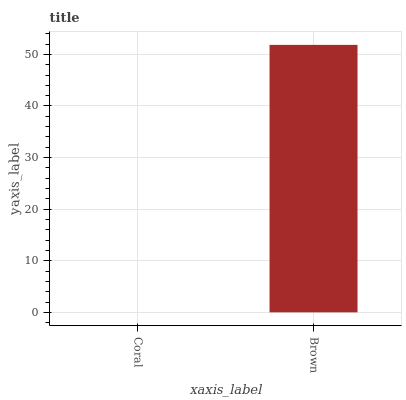Is Brown the minimum?
Answer yes or no. No. Is Brown greater than Coral?
Answer yes or no. Yes. Is Coral less than Brown?
Answer yes or no. Yes. Is Coral greater than Brown?
Answer yes or no. No. Is Brown less than Coral?
Answer yes or no. No. Is Brown the high median?
Answer yes or no. Yes. Is Coral the low median?
Answer yes or no. Yes. Is Coral the high median?
Answer yes or no. No. Is Brown the low median?
Answer yes or no. No. 